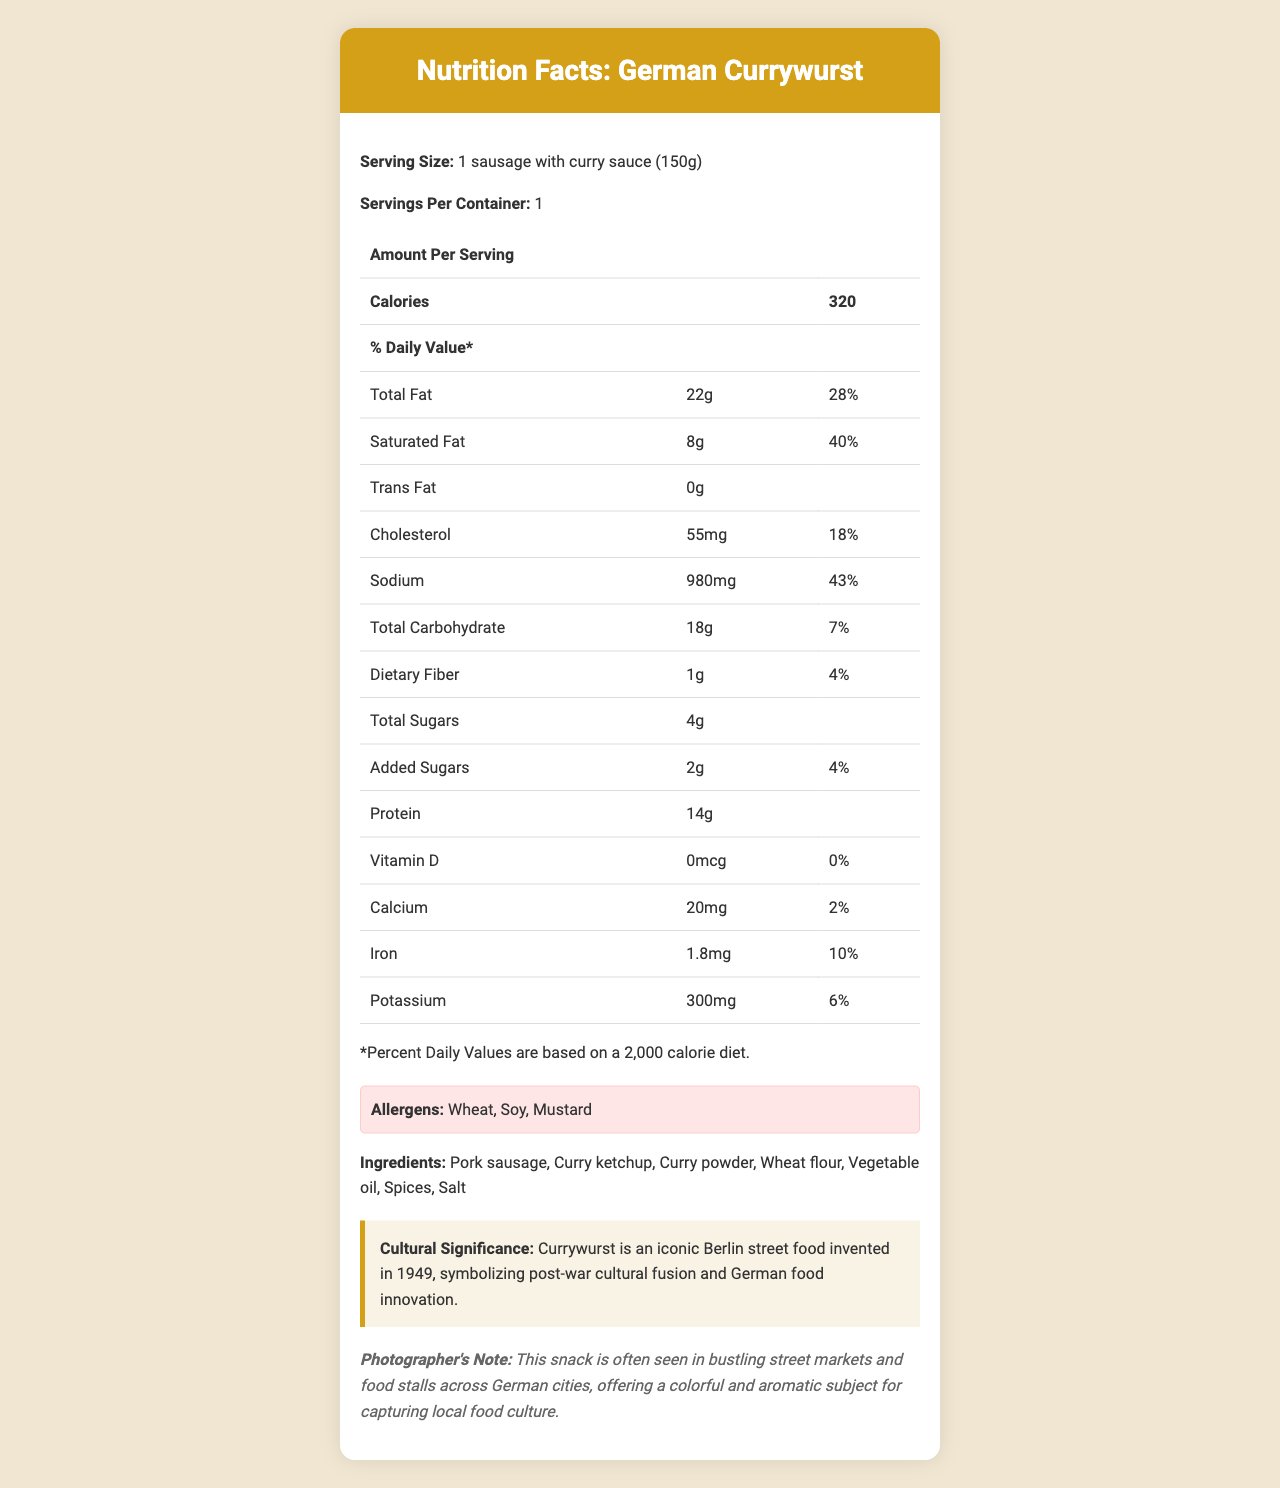what is the serving size of the German Currywurst? Serving size information is given at the beginning of the document under the "Serving Size" section.
Answer: 1 sausage with curry sauce (150g) how many calories are in one serving of the German Currywurst? The calorie count for one serving is listed in the "Amount Per Serving" section of the nutrition table.
Answer: 320 what is the total fat content in one serving? The total fat amount is found in the nutrition table under "Total Fat."
Answer: 22g what is the daily value percentage for saturated fat in one serving? The daily value percentage for saturated fat is listed in the nutrition table under "Saturated Fat."
Answer: 40% which allergens are present in the German Currywurst? The allergens are listed in the "Allergens" section of the document.
Answer: Wheat, Soy, Mustard what is the cultural significance of Currywurst? The cultural significance is detailed in the "Cultural Significance" section of the document.
Answer: Currywurst is an iconic Berlin street food invented in 1949, symbolizing post-war cultural fusion and German food innovation. how much sodium does one serving of German Currywurst contain? The amount of sodium per serving is specified in the nutrition table under "Sodium."
Answer: 980mg which two ingredients are used to make the German Currywurst sauce? The ingredients are listed in the "Ingredients" section of the document.
Answer: Curry ketchup, Curry powder what percentage of daily value for dietary fiber is provided by one serving? The daily value percentage for dietary fiber is stated in the nutrition table under "Dietary Fiber."
Answer: 4% how much calcium is in one serving of the German Currywurst? A. 10mg B. 20mg C. 30mg The calcium amount per serving is listed in the nutrition table under "Calcium."
Answer: B. 20mg which of the following nutrients is not present in the German Currywurst? I. Vitamin D II. Trans Fat III. Protein ​ The nutrition table shows 0 mcg of Vitamin D, whereas trans fat and protein have listed amounts.
Answer: I. Vitamin D is there any iron content in the German Currywurst? The nutrition table lists 1.8mg of iron, confirming its presence.
Answer: Yes summarize the main idea of the document. The document is an in-depth nutrition label that offers comprehensive information on the German Currywurst, including its nutritional content, cultural significance, and relevant notes for photographers.
Answer: The document provides detailed nutrition information about German Currywurst, listing its serving size, calorie count, macronutrient content, and daily value percentages for various nutrients. It also highlights allergens, ingredients, and the cultural significance of this traditional European street food. The photographer's note emphasizes its visual and cultural representation in street markets. how many calories come from sugars in one serving? The document lists total sugars and added sugars but does not provide a direct calculation of the calories derived specifically from sugars.
Answer: Not enough information 